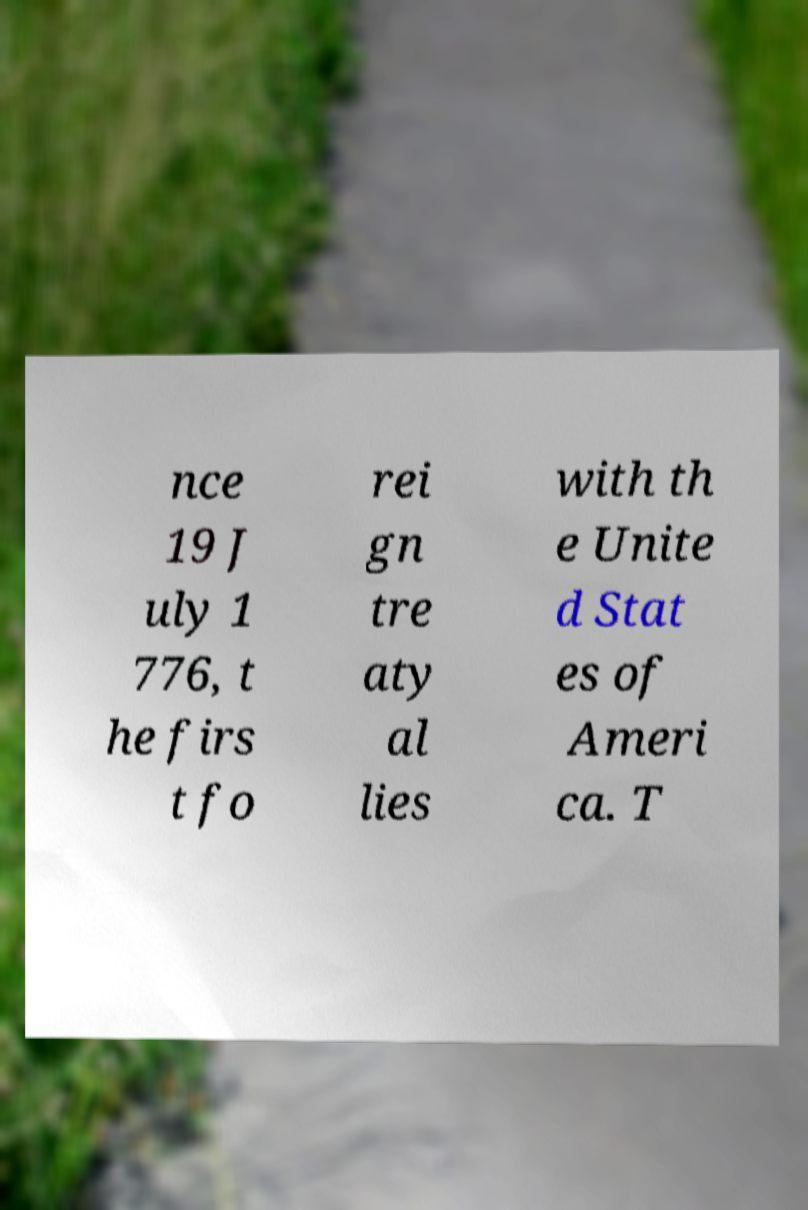Please read and relay the text visible in this image. What does it say? nce 19 J uly 1 776, t he firs t fo rei gn tre aty al lies with th e Unite d Stat es of Ameri ca. T 